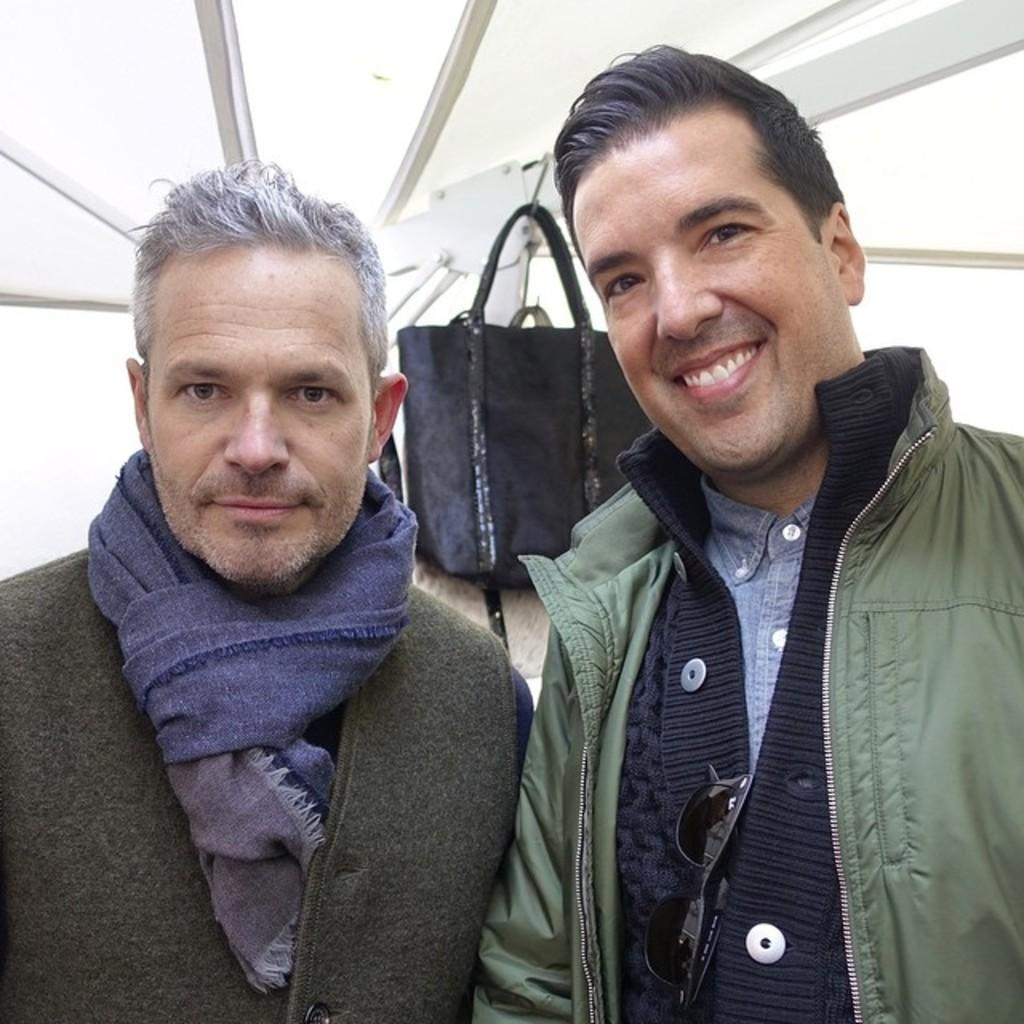How many people are in the image? There are two men in the image. What are the men doing in the image? The men are standing and smiling. Can you describe any objects in the image besides the men? There is a bag hung on a rod in the image. What type of sponge can be seen growing on the men's faces in the image? There is no sponge visible on the men's faces in the image. What kind of seed is being planted by the men in the image? There is no seed or planting activity depicted in the image. 